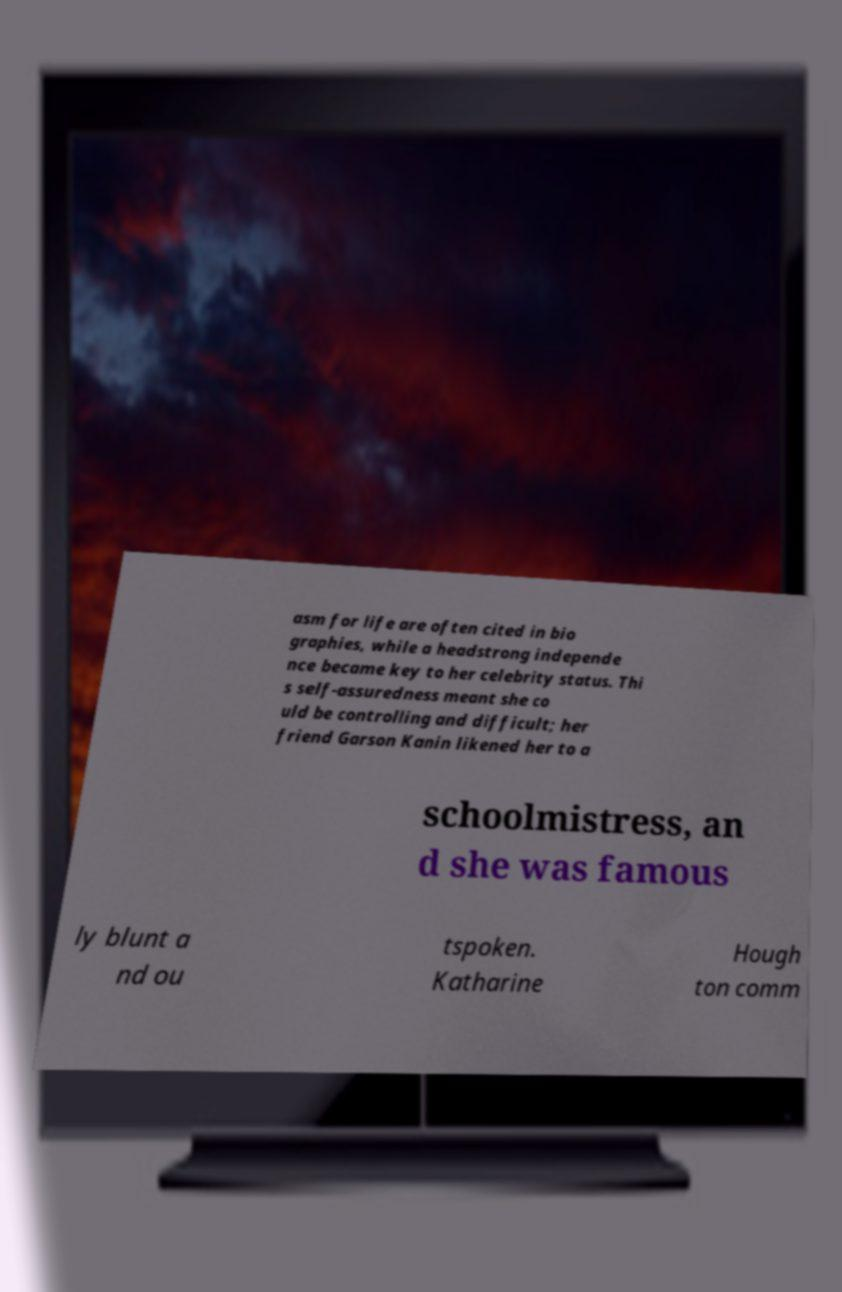Please identify and transcribe the text found in this image. asm for life are often cited in bio graphies, while a headstrong independe nce became key to her celebrity status. Thi s self-assuredness meant she co uld be controlling and difficult; her friend Garson Kanin likened her to a schoolmistress, an d she was famous ly blunt a nd ou tspoken. Katharine Hough ton comm 